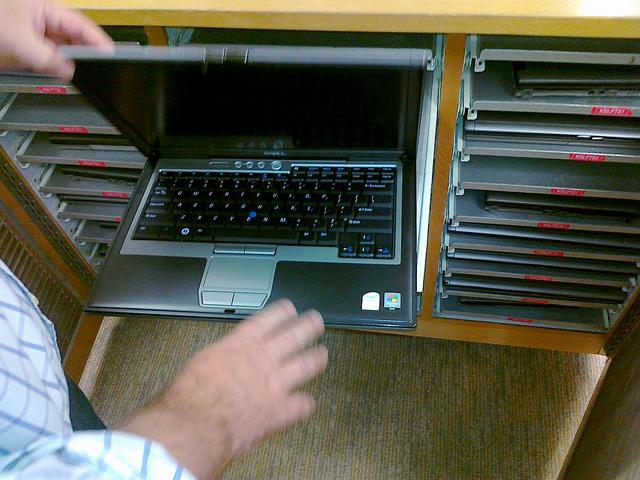What is the person touching?
Short answer required. Laptop. Is the computer on?
Write a very short answer. No. What is on either side of the computer?
Write a very short answer. Shelves. Is the laptop on?
Quick response, please. No. 